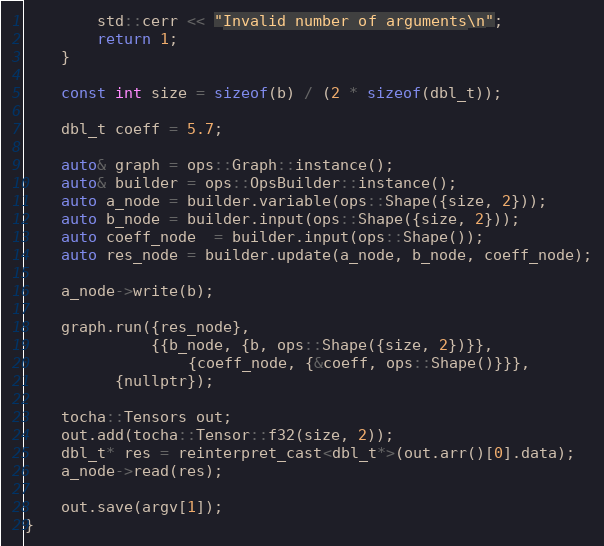<code> <loc_0><loc_0><loc_500><loc_500><_Cuda_>        std::cerr << "Invalid number of arguments\n";
        return 1;
    }

    const int size = sizeof(b) / (2 * sizeof(dbl_t));

    dbl_t coeff = 5.7;

    auto& graph = ops::Graph::instance();
    auto& builder = ops::OpsBuilder::instance();
    auto a_node = builder.variable(ops::Shape({size, 2}));
    auto b_node = builder.input(ops::Shape({size, 2}));
    auto coeff_node  = builder.input(ops::Shape());
    auto res_node = builder.update(a_node, b_node, coeff_node);

    a_node->write(b);

    graph.run({res_node},
              {{b_node, {b, ops::Shape({size, 2})}},
                  {coeff_node, {&coeff, ops::Shape()}}},
	      {nullptr});

    tocha::Tensors out;
    out.add(tocha::Tensor::f32(size, 2));
    dbl_t* res = reinterpret_cast<dbl_t*>(out.arr()[0].data);
    a_node->read(res);
    
    out.save(argv[1]);
}
</code> 